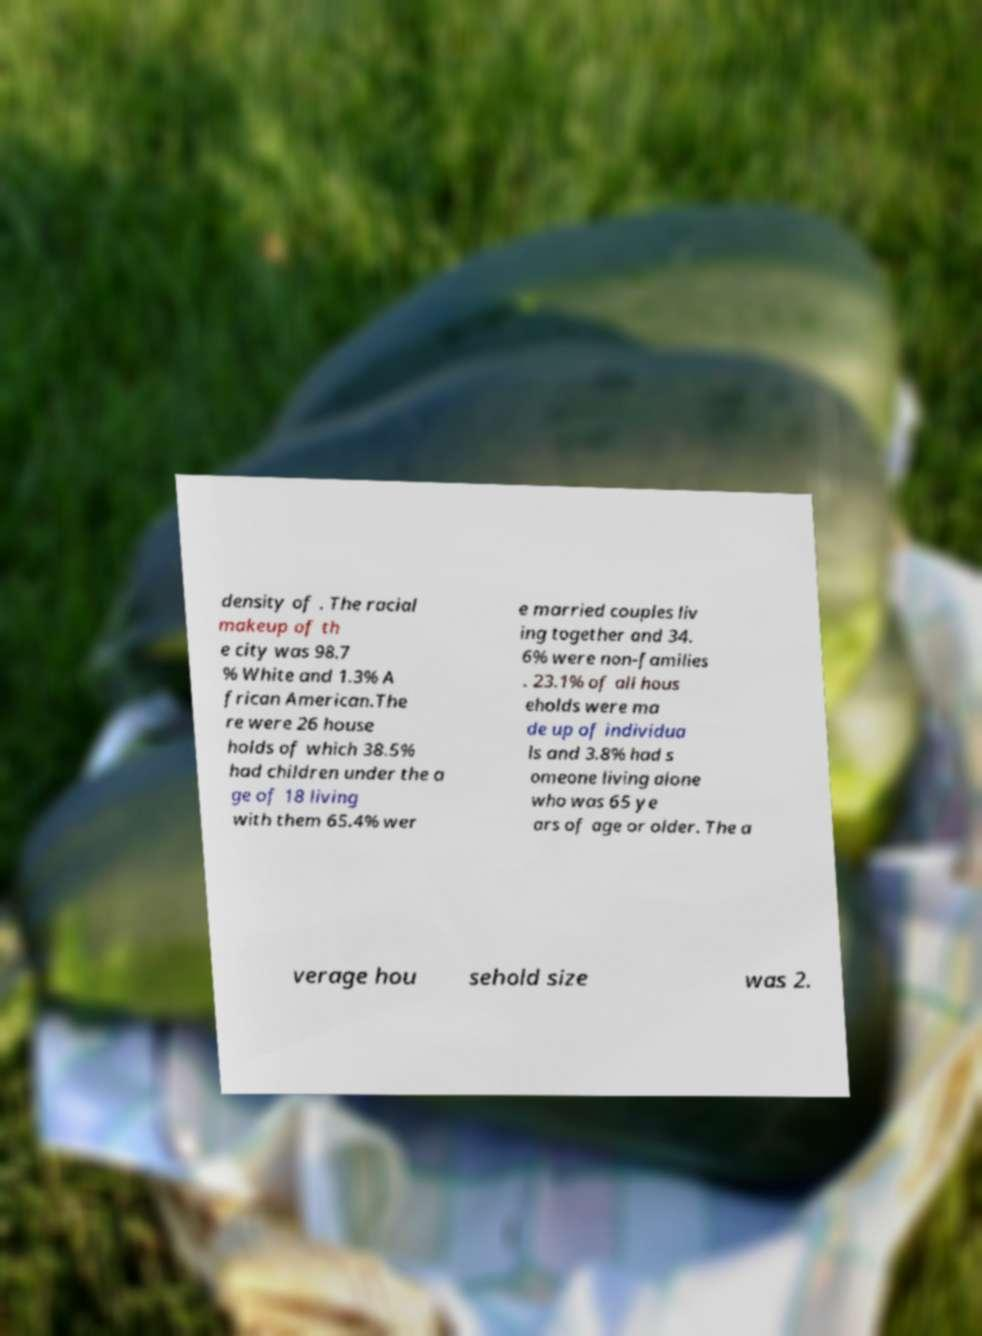Can you read and provide the text displayed in the image?This photo seems to have some interesting text. Can you extract and type it out for me? density of . The racial makeup of th e city was 98.7 % White and 1.3% A frican American.The re were 26 house holds of which 38.5% had children under the a ge of 18 living with them 65.4% wer e married couples liv ing together and 34. 6% were non-families . 23.1% of all hous eholds were ma de up of individua ls and 3.8% had s omeone living alone who was 65 ye ars of age or older. The a verage hou sehold size was 2. 